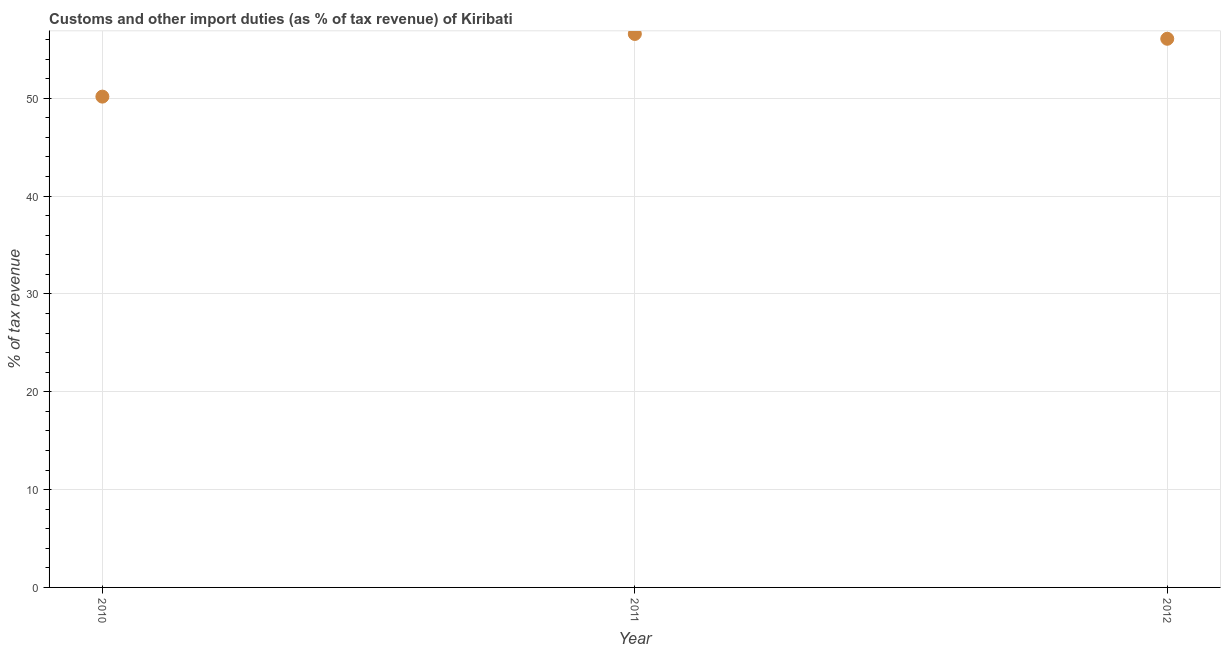What is the customs and other import duties in 2012?
Make the answer very short. 56.08. Across all years, what is the maximum customs and other import duties?
Your answer should be very brief. 56.57. Across all years, what is the minimum customs and other import duties?
Offer a very short reply. 50.17. In which year was the customs and other import duties maximum?
Offer a very short reply. 2011. What is the sum of the customs and other import duties?
Your answer should be compact. 162.81. What is the difference between the customs and other import duties in 2011 and 2012?
Keep it short and to the point. 0.49. What is the average customs and other import duties per year?
Make the answer very short. 54.27. What is the median customs and other import duties?
Your answer should be compact. 56.08. In how many years, is the customs and other import duties greater than 12 %?
Offer a very short reply. 3. What is the ratio of the customs and other import duties in 2010 to that in 2011?
Your answer should be compact. 0.89. Is the customs and other import duties in 2010 less than that in 2012?
Your response must be concise. Yes. Is the difference between the customs and other import duties in 2011 and 2012 greater than the difference between any two years?
Keep it short and to the point. No. What is the difference between the highest and the second highest customs and other import duties?
Offer a terse response. 0.49. Is the sum of the customs and other import duties in 2011 and 2012 greater than the maximum customs and other import duties across all years?
Give a very brief answer. Yes. What is the difference between the highest and the lowest customs and other import duties?
Offer a terse response. 6.4. Does the customs and other import duties monotonically increase over the years?
Your answer should be compact. No. How many dotlines are there?
Give a very brief answer. 1. What is the difference between two consecutive major ticks on the Y-axis?
Offer a very short reply. 10. Are the values on the major ticks of Y-axis written in scientific E-notation?
Your answer should be very brief. No. What is the title of the graph?
Keep it short and to the point. Customs and other import duties (as % of tax revenue) of Kiribati. What is the label or title of the Y-axis?
Your response must be concise. % of tax revenue. What is the % of tax revenue in 2010?
Your answer should be compact. 50.17. What is the % of tax revenue in 2011?
Give a very brief answer. 56.57. What is the % of tax revenue in 2012?
Ensure brevity in your answer.  56.08. What is the difference between the % of tax revenue in 2010 and 2011?
Make the answer very short. -6.4. What is the difference between the % of tax revenue in 2010 and 2012?
Provide a short and direct response. -5.91. What is the difference between the % of tax revenue in 2011 and 2012?
Ensure brevity in your answer.  0.49. What is the ratio of the % of tax revenue in 2010 to that in 2011?
Make the answer very short. 0.89. What is the ratio of the % of tax revenue in 2010 to that in 2012?
Offer a terse response. 0.9. 